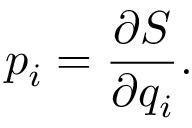<formula> <loc_0><loc_0><loc_500><loc_500>p _ { i } = { \frac { \partial S } { \partial q _ { i } } } .</formula> 